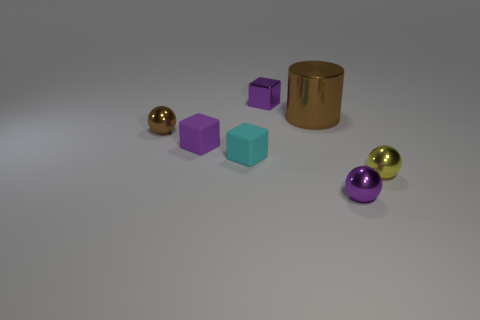Are there any big brown balls that have the same material as the large brown thing?
Provide a succinct answer. No. What shape is the metallic object that is behind the small cyan rubber object and in front of the large brown cylinder?
Your answer should be compact. Sphere. What number of tiny things are blocks or metal objects?
Offer a terse response. 6. What is the large cylinder made of?
Your answer should be very brief. Metal. How many other things are the same shape as the tiny cyan rubber object?
Ensure brevity in your answer.  2. How big is the cyan rubber cube?
Provide a short and direct response. Small. There is a thing that is both behind the tiny purple matte object and to the left of the small cyan cube; what size is it?
Your response must be concise. Small. The small purple shiny object that is in front of the tiny purple rubber cube has what shape?
Offer a very short reply. Sphere. Do the purple sphere and the tiny purple block in front of the tiny brown thing have the same material?
Give a very brief answer. No. Is the small yellow metallic object the same shape as the small cyan matte object?
Offer a very short reply. No. 